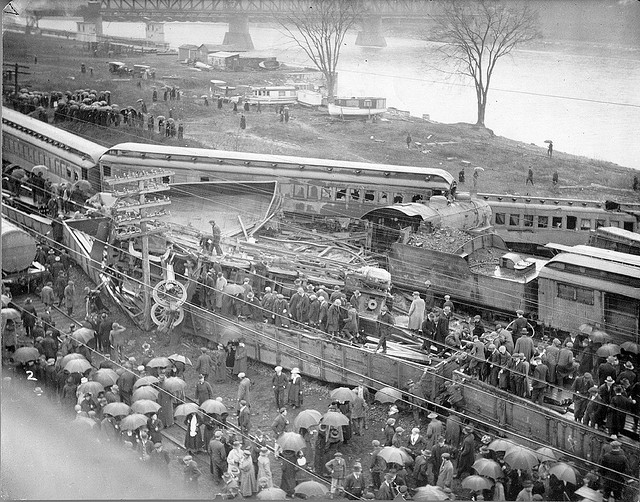<image>What color if the train? I am not sure what the color of the train is. It could be gray or white, or the photograph could be in black and white. What color if the train? The color of the train is gray. However, the photograph is black and white, so it is uncertain. 